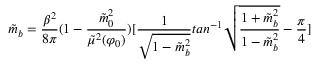<formula> <loc_0><loc_0><loc_500><loc_500>\tilde { m } _ { b } = { \frac { \beta ^ { 2 } } { 8 \pi } } ( 1 - { \frac { \tilde { m } _ { 0 } ^ { 2 } } { \tilde { \mu } ^ { 2 } ( \varphi _ { 0 } ) } } ) [ { \frac { 1 } { \sqrt { 1 - \tilde { m } _ { b } ^ { 2 } } } } t a n ^ { - 1 } \sqrt { { \frac { 1 + \tilde { m } _ { b } ^ { 2 } } { 1 - \tilde { m } _ { b } ^ { 2 } } } } - { \frac { \pi } { 4 } } ]</formula> 